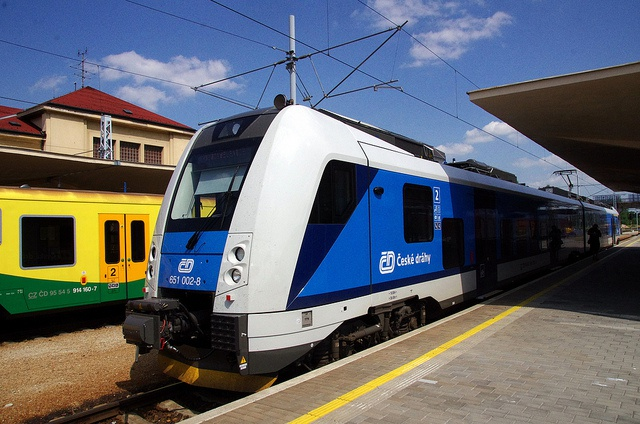Describe the objects in this image and their specific colors. I can see train in blue, black, lightgray, and darkgray tones, train in blue, black, gold, darkgreen, and orange tones, people in black and blue tones, and people in black and blue tones in this image. 